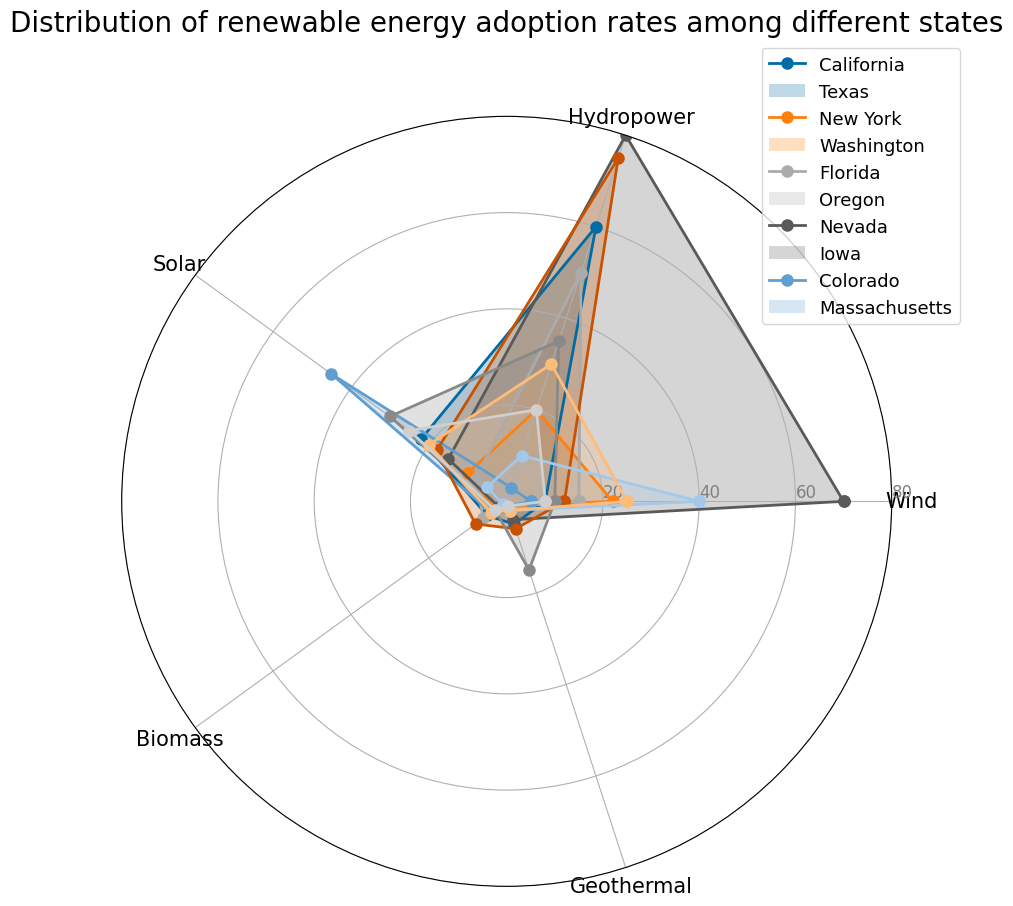Which state has the highest adoption rate of wind energy? By looking at the length of the plot's segment for Wind energy, Washington state has the segment extending to 70, which is the highest among all states.
Answer: Washington Which state has the lowest adoption rate of biomass energy? By comparing the lengths of the plot's segments for Biomass energy, Iowa has the smallest segment extending to 1.
Answer: Iowa What is the average adoption rate of solar energy across all states? Sum the Solar energy values: 22 + 10 + 8 + 15 + 45 + 18 + 30 + 5 + 20 + 25 = 198. Then, divide by the number of states (10): 198 / 10 = 19.8
Answer: 19.8 How does California's adoption rate for hydropower compare to Oregon's? Looking at the plot's segments for Hydropower energy, California's segment extends to 60, whereas Oregon's extends to 75. So, Oregon's rate is higher.
Answer: Oregon Which state has the most balanced adoption rates across all renewable energy types? By observing the evenness in the length of the segments across all categories, California and Colorado both demonstrate relatively balanced adoption rates without any single category dominating. To break the tie: consider the standard deviation of the rates. California (8, 60, 22, 5, 5) has an SD of about 22.66; Colorado (25, 30, 20, 4, 2) has an SD of about 11.77, making Colorado more balanced.
Answer: Colorado Is there any state with a high adoption rate of geothermal energy but low adoption rates in other categories? By observing the length of the segments for Geothermal energy, Nevada stands out with 15 for Geothermal but relatively lower values (Wind: 10, Hydropower: 35, Solar: 30, Biomass: 3) in other categories.
Answer: Nevada Calculate the total adoption rate of all renewable energy types combined for Texas. Sum Texas's values: 22 (Wind) + 20 (Hydropower) + 10 (Solar) + 3 (Biomass) + 1 (Geothermal) = 56
Answer: 56 By how much does Washington's hydropower adoption rate exceed New York's? Washington's Hydropower rate is 80, and New York's is 50. The difference is 80 - 50 = 30.
Answer: 30 Which state has the highest adoption rate for solar energy, and what is that rate? By examining the longest segment for Solar energy, Florida has the highest rate with a value of 45.
Answer: Florida What is the median adoption rate of wind energy across all states? List Wind energy values: 8, 22, 15, 70, 5, 12, 10, 40, 25, 8. Arranged in order: 5, 8, 8, 10, 12, 15, 22, 25, 40, 70. The median is the middle value: (12 + 15) / 2 = 13.5
Answer: 13.5 